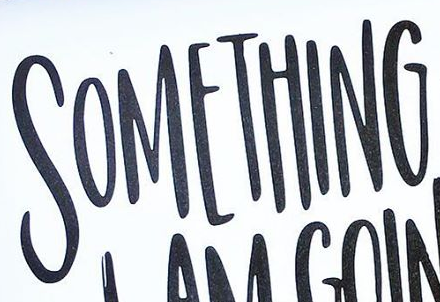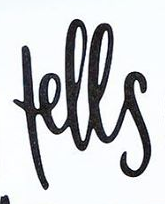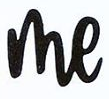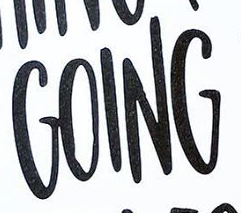What words are shown in these images in order, separated by a semicolon? SOMETHING; fells; me; GOING 